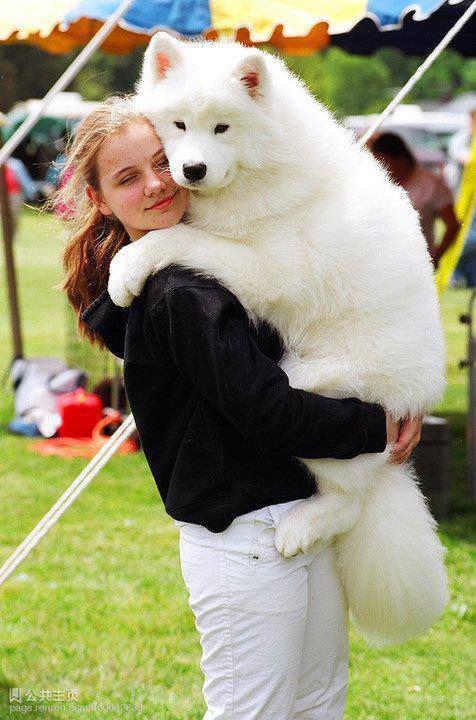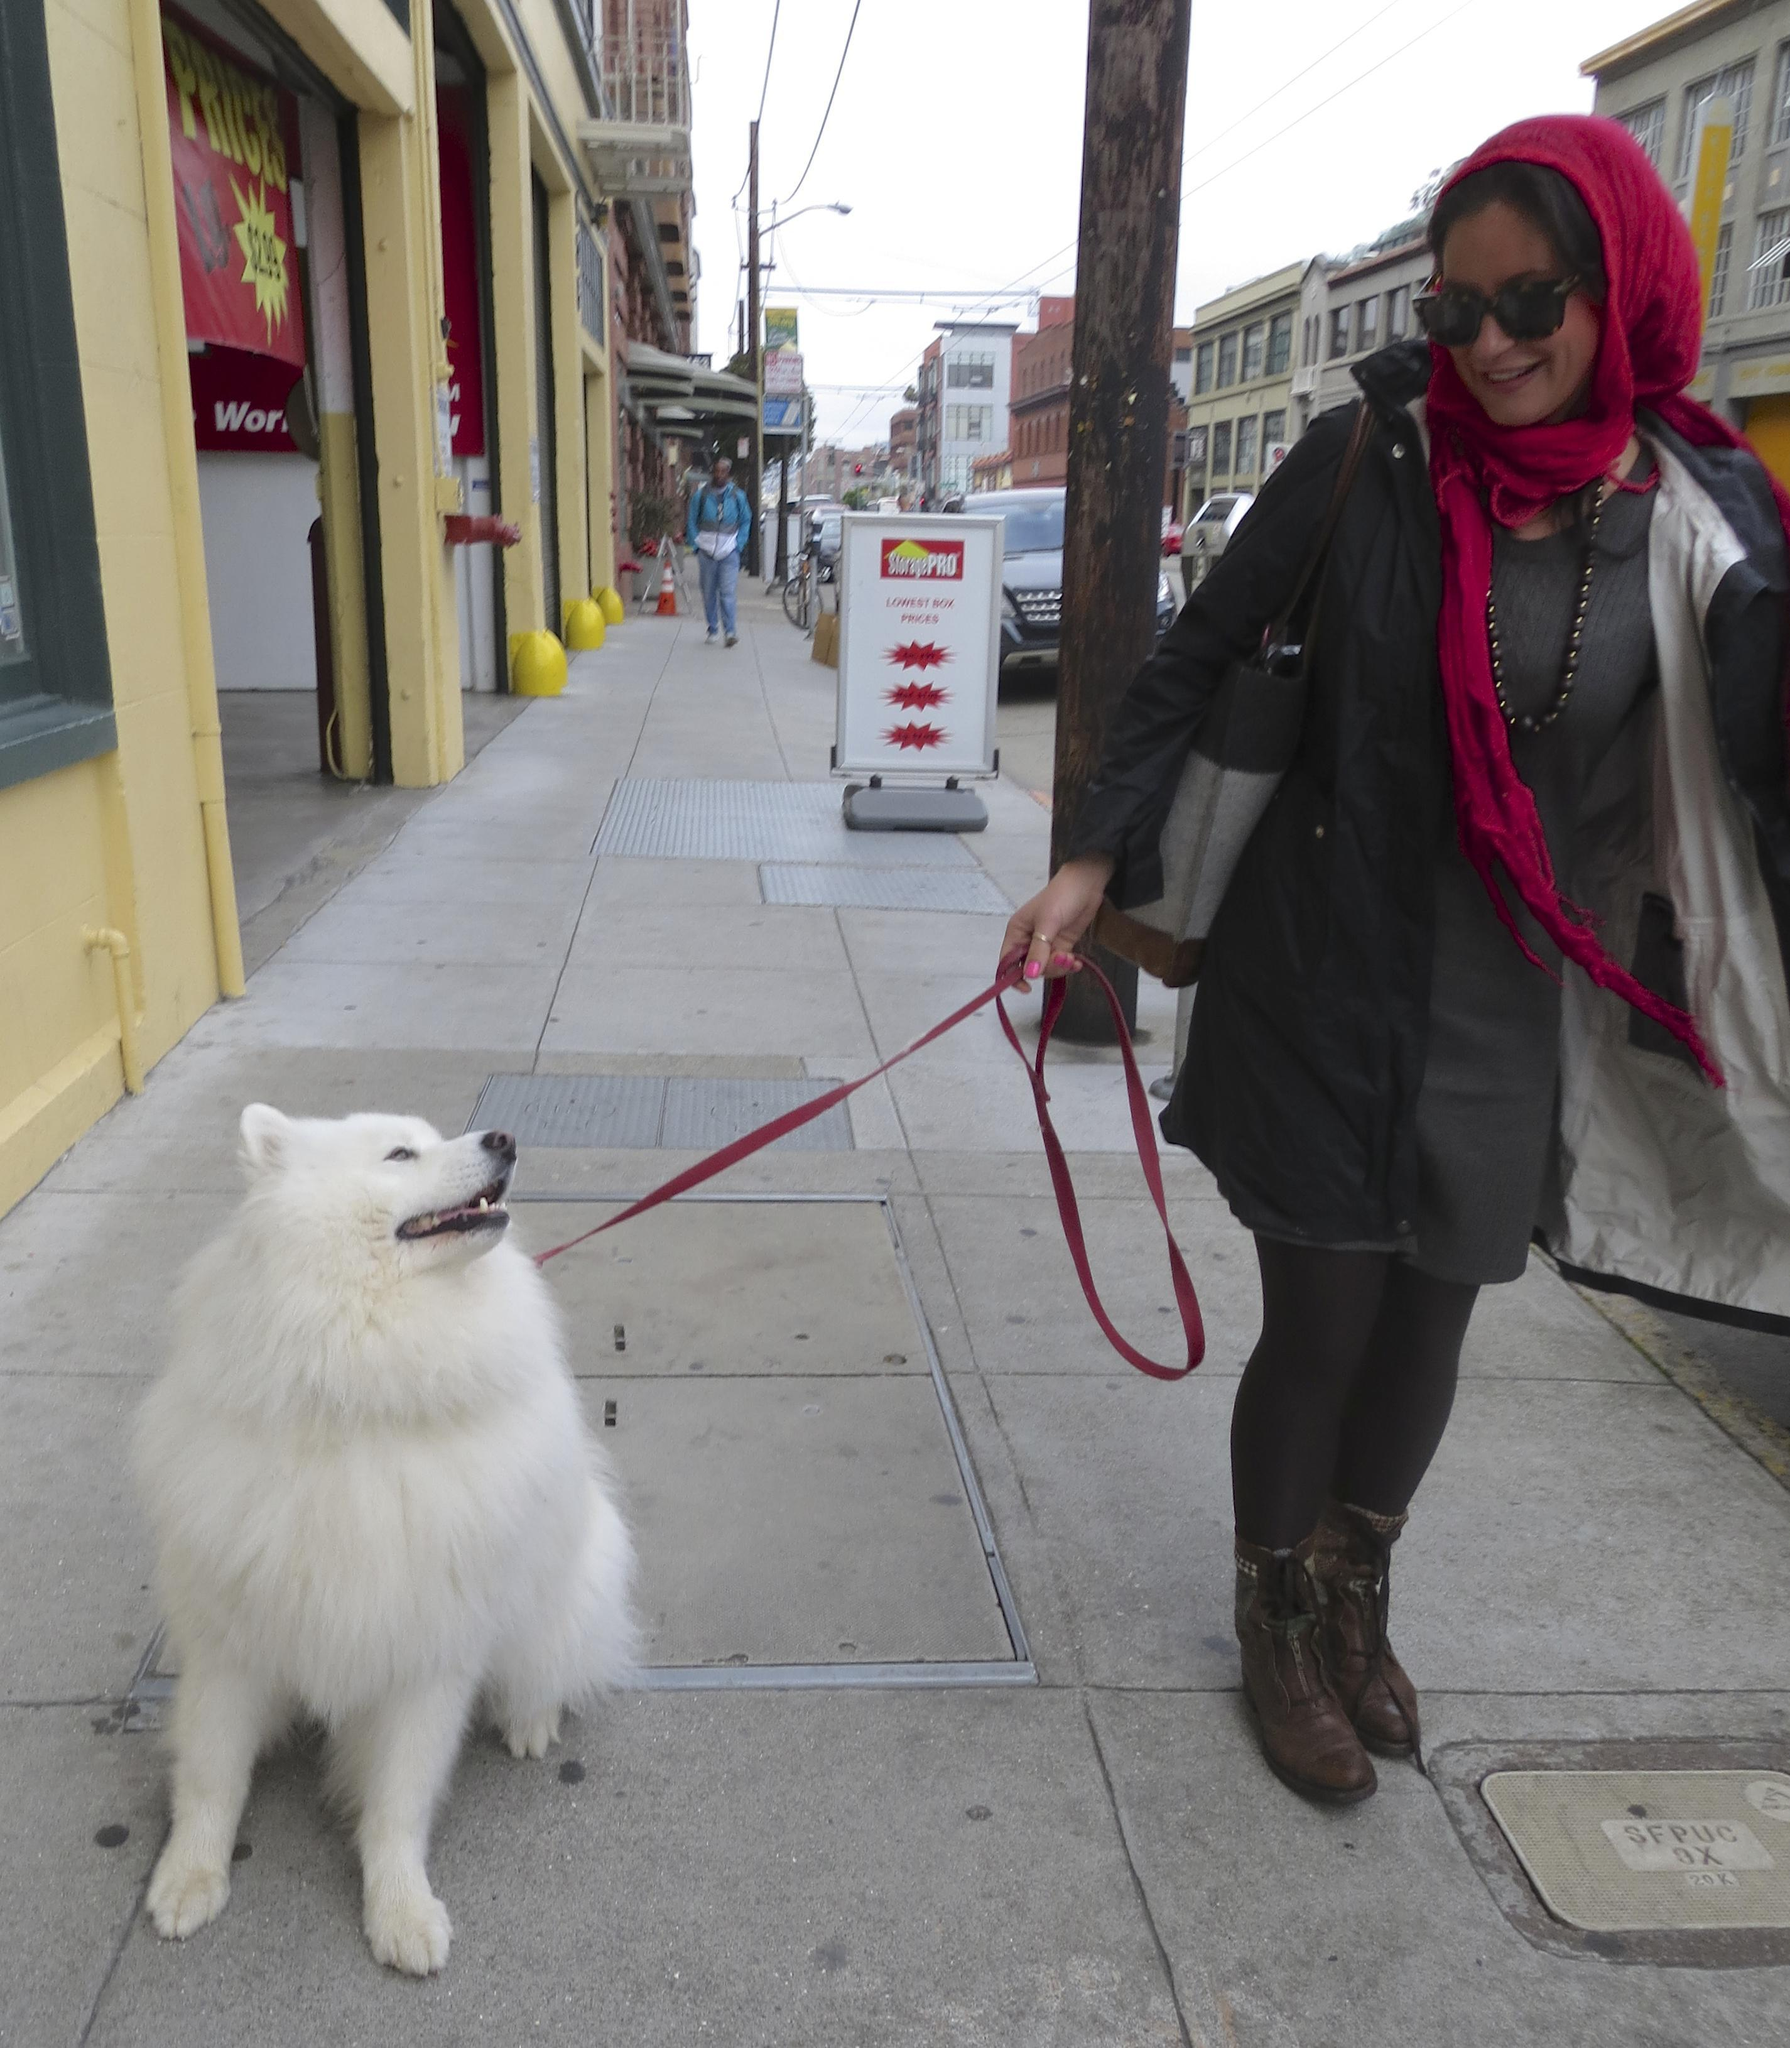The first image is the image on the left, the second image is the image on the right. Analyze the images presented: Is the assertion "One image features a man in a suit reaching toward a standing white dog in front of white lattice fencing, and the other image features a team of hitched white dogs with a rider behind them." valid? Answer yes or no. No. The first image is the image on the left, the second image is the image on the right. Evaluate the accuracy of this statement regarding the images: "Dogs are running together.". Is it true? Answer yes or no. No. 